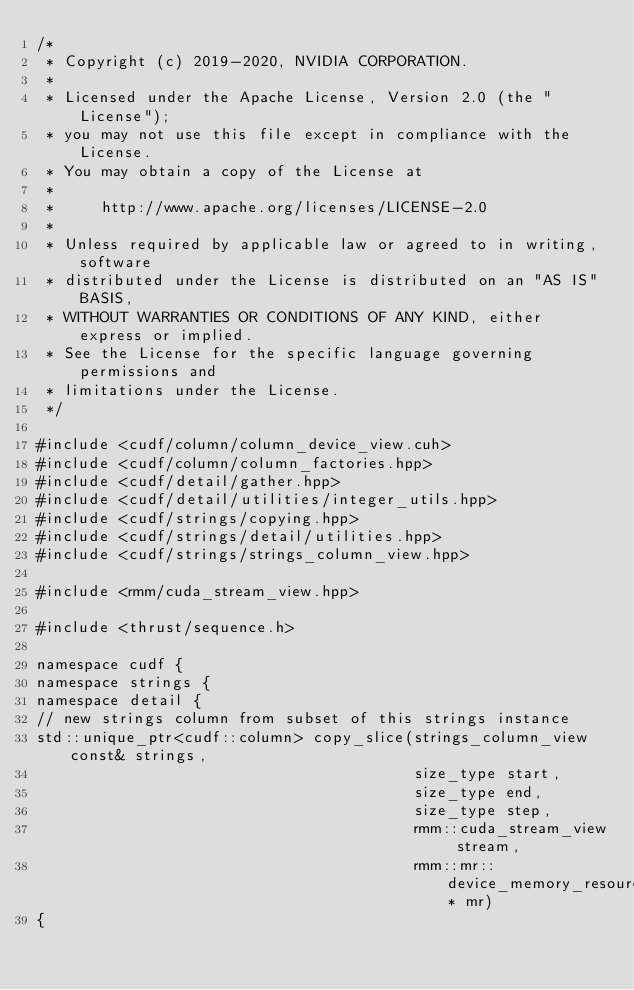<code> <loc_0><loc_0><loc_500><loc_500><_Cuda_>/*
 * Copyright (c) 2019-2020, NVIDIA CORPORATION.
 *
 * Licensed under the Apache License, Version 2.0 (the "License");
 * you may not use this file except in compliance with the License.
 * You may obtain a copy of the License at
 *
 *     http://www.apache.org/licenses/LICENSE-2.0
 *
 * Unless required by applicable law or agreed to in writing, software
 * distributed under the License is distributed on an "AS IS" BASIS,
 * WITHOUT WARRANTIES OR CONDITIONS OF ANY KIND, either express or implied.
 * See the License for the specific language governing permissions and
 * limitations under the License.
 */

#include <cudf/column/column_device_view.cuh>
#include <cudf/column/column_factories.hpp>
#include <cudf/detail/gather.hpp>
#include <cudf/detail/utilities/integer_utils.hpp>
#include <cudf/strings/copying.hpp>
#include <cudf/strings/detail/utilities.hpp>
#include <cudf/strings/strings_column_view.hpp>

#include <rmm/cuda_stream_view.hpp>

#include <thrust/sequence.h>

namespace cudf {
namespace strings {
namespace detail {
// new strings column from subset of this strings instance
std::unique_ptr<cudf::column> copy_slice(strings_column_view const& strings,
                                         size_type start,
                                         size_type end,
                                         size_type step,
                                         rmm::cuda_stream_view stream,
                                         rmm::mr::device_memory_resource* mr)
{</code> 